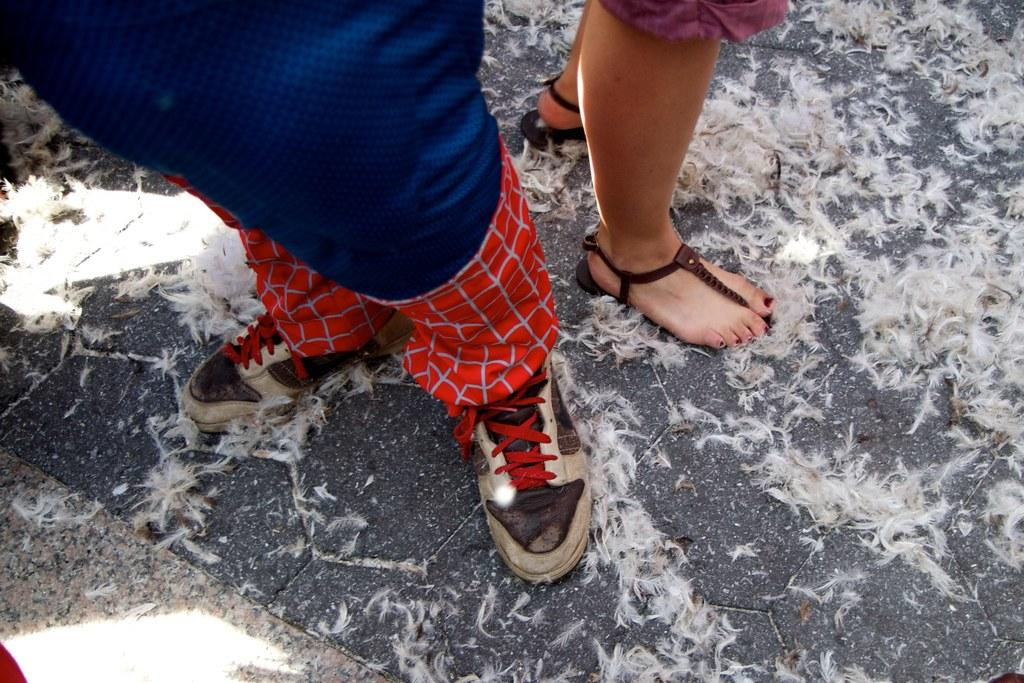How many people are present in the image? There are 2 people standing in the image. What can be found on the ground in the image? There are bird feathers on the ground in the image. What type of waves can be seen crashing on the shore in the image? There is no shore or waves present in the image; it features two people and bird feathers on the ground. 